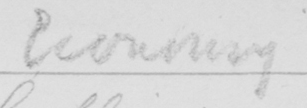What does this handwritten line say? Economy 